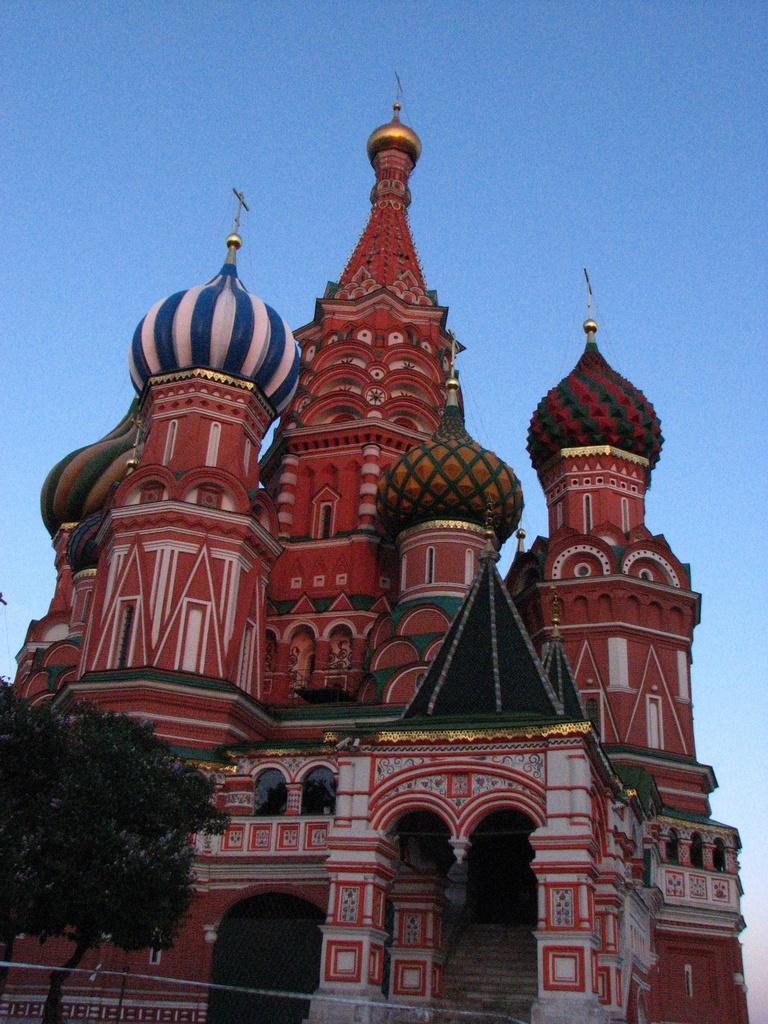Please provide a concise description of this image. In this image there is a castle. In the bottom left there is a tree. At the top there is the sky. 